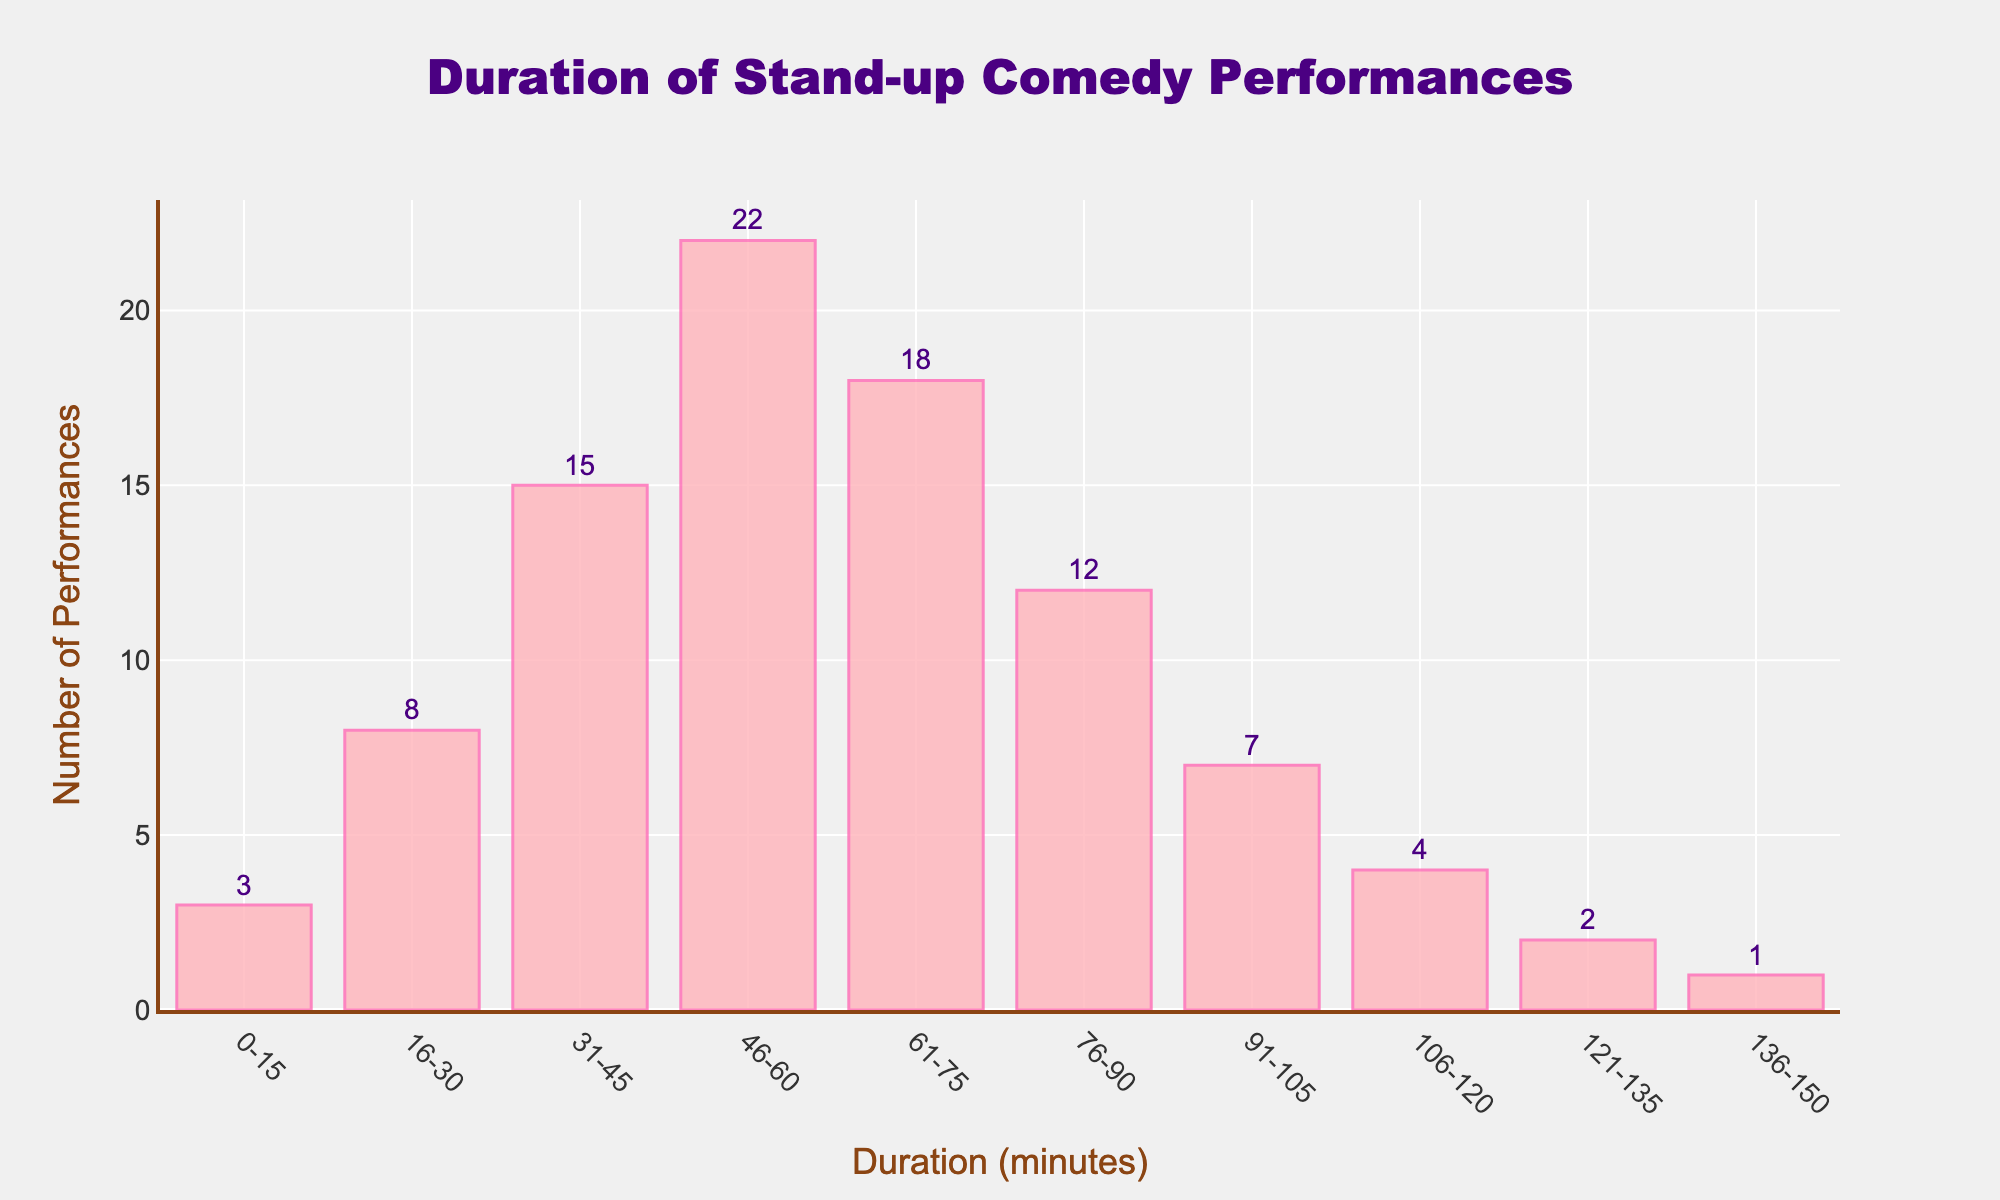What's the title of the plot? The title is located at the top center of the plot. It gives an overall description of what the plot is showing.
Answer: Duration of Stand-up Comedy Performances What is the most common duration range for performances? By examining the height of the bars, the tallest bar represents the most common duration range.
Answer: 46-60 minutes How many performance durations fall between 91 and 120 minutes? Identify the bars corresponding to the 91-105 and 106-120 minutes ranges and sum their heights.
Answer: 7 + 4 = 11 Which duration range has the least number of performances? Look for the shortest bar in the histogram.
Answer: 136-150 minutes How many performances last more than 1 hour? Sum the number of performances for the duration ranges longer than 60 minutes by adding the values above 60 minutes.
Answer: 18 + 12 + 7 + 4 + 2 + 1 = 44 What is the total number of performances? Add the heights of all the bars to get the total number of performances.
Answer: 3 + 8 + 15 + 22 + 18 + 12 + 7 + 4 + 2 + 1 = 92 What color is used for the bars in the histogram? The bars’ color can be observed directly from the plot. It appears as a light pink shade.
Answer: Light pink How does the number of performances in the 31-45 minutes range compare to the number in the 46-60 minutes range? Compare the heights of the bars corresponding to these ranges. The bar for 46-60 minutes is higher.
Answer: The 46-60 minutes range has more performances Which duration ranges have more than 10 performances? Identify the bars that exceed a height of 10 by checking their values.
Answer: 31-45, 46-60, 61-75, 76-90 minutes What is the difference in the number of performances between the 16-30 minutes range and the 76-90 minutes range? Subtract the number of performances of the 16-30 minutes range from the 76-90 minutes range.
Answer: 12 - 8 = 4 